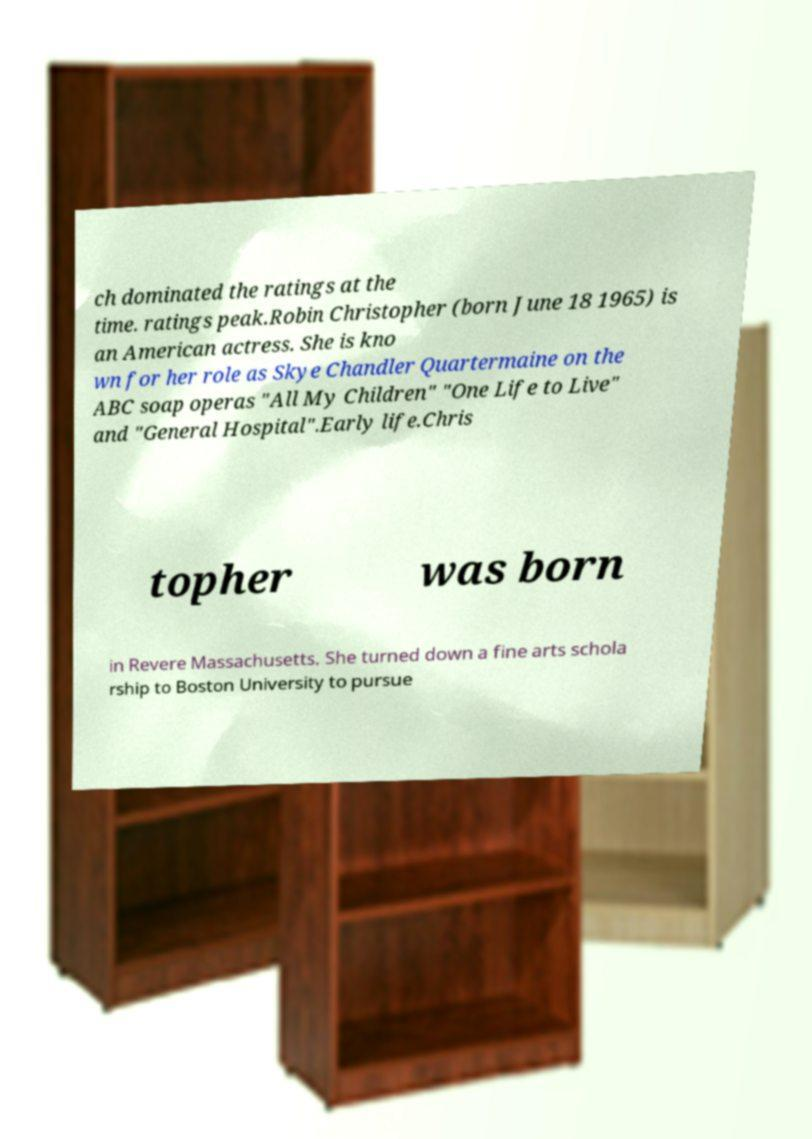What messages or text are displayed in this image? I need them in a readable, typed format. ch dominated the ratings at the time. ratings peak.Robin Christopher (born June 18 1965) is an American actress. She is kno wn for her role as Skye Chandler Quartermaine on the ABC soap operas "All My Children" "One Life to Live" and "General Hospital".Early life.Chris topher was born in Revere Massachusetts. She turned down a fine arts schola rship to Boston University to pursue 